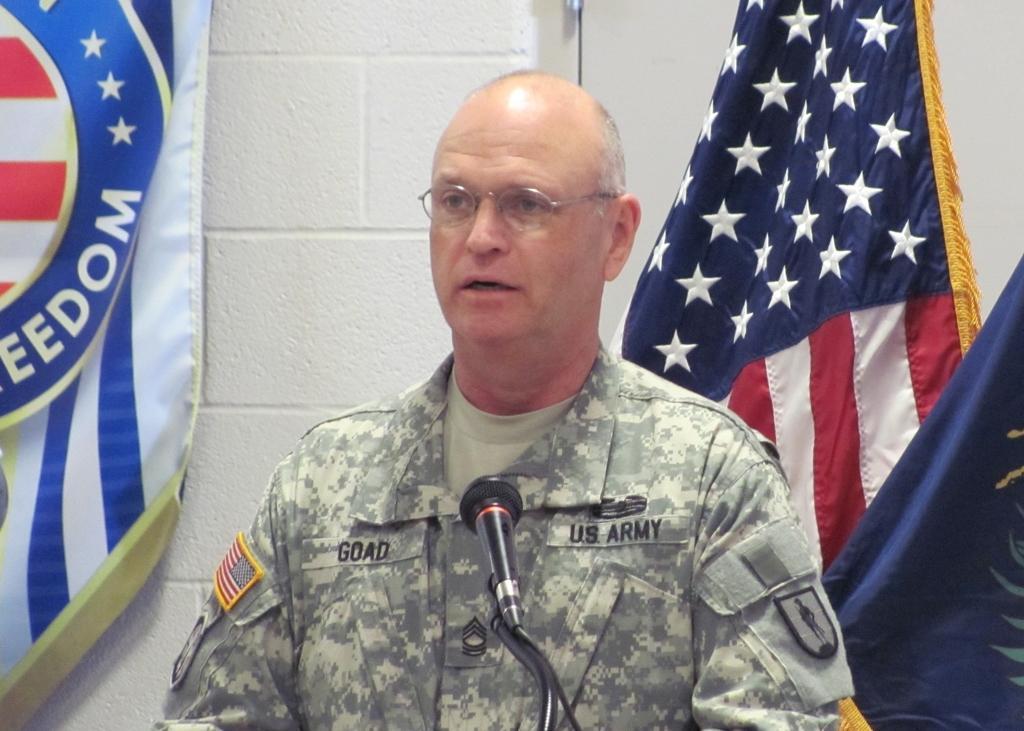Describe this image in one or two sentences. In this image we can see a man and a mic is placed in front of him. In the background there are flags and wall. 